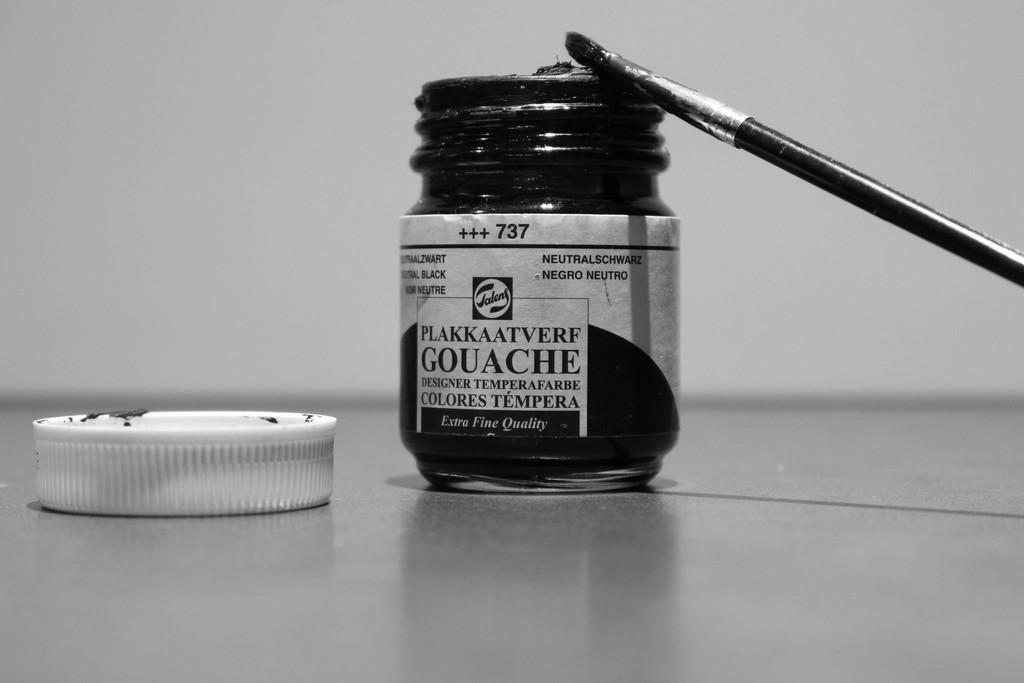<image>
Create a compact narrative representing the image presented. Paintbrush and jar of black paint named Plakkaatverf Gouache. 